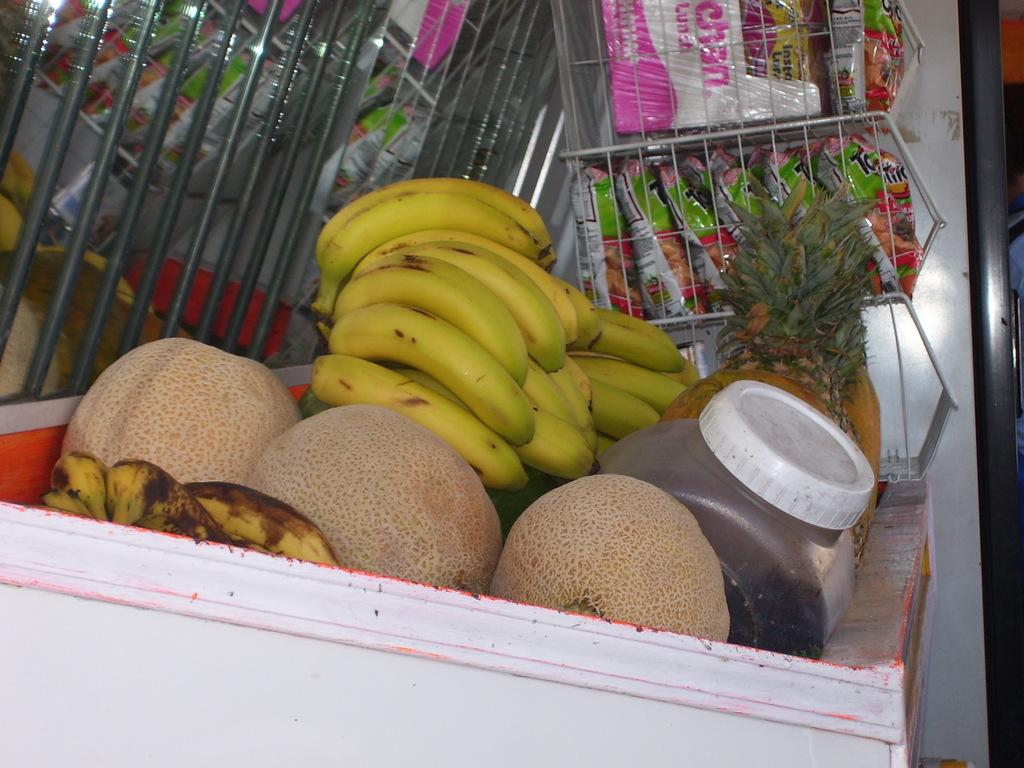What types of food can be seen in the foreground of the image? There are fruits in the foreground of the image. What else can be seen in the image besides the fruits? There are edible items in the background of the image. What scent can be detected from the boys in the image? There are no boys present in the image, so it is not possible to detect any scent from them. 